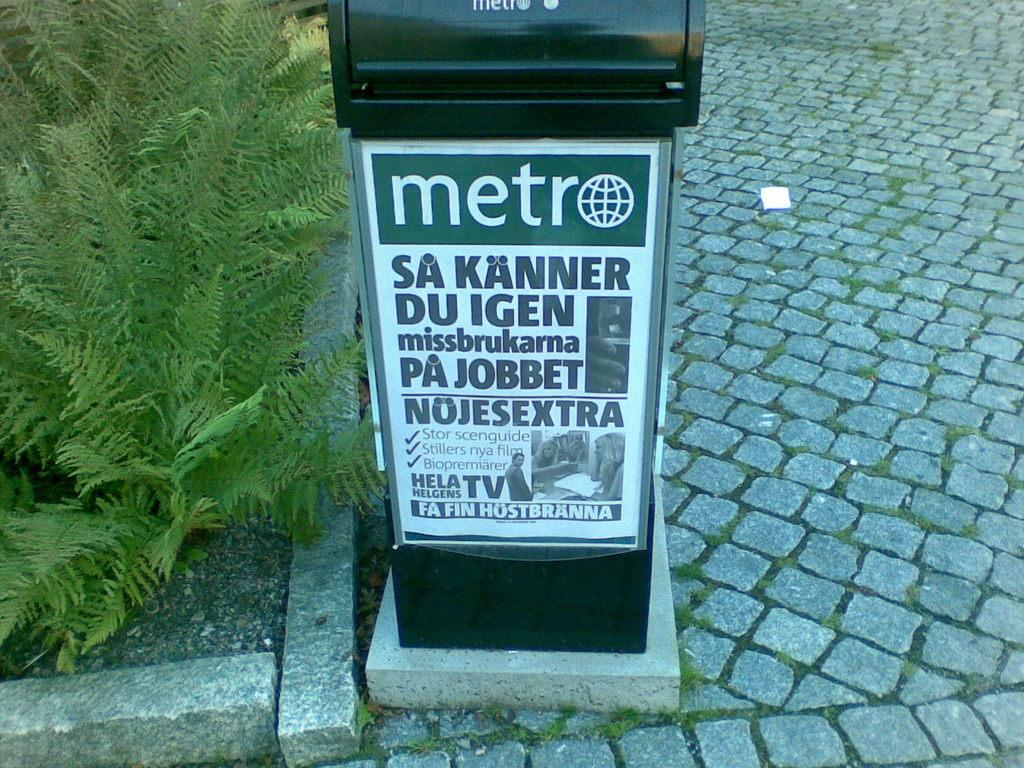Provide a one-sentence caption for the provided image. A Metro advertisement in Sweden is outdoors on a brick path. 